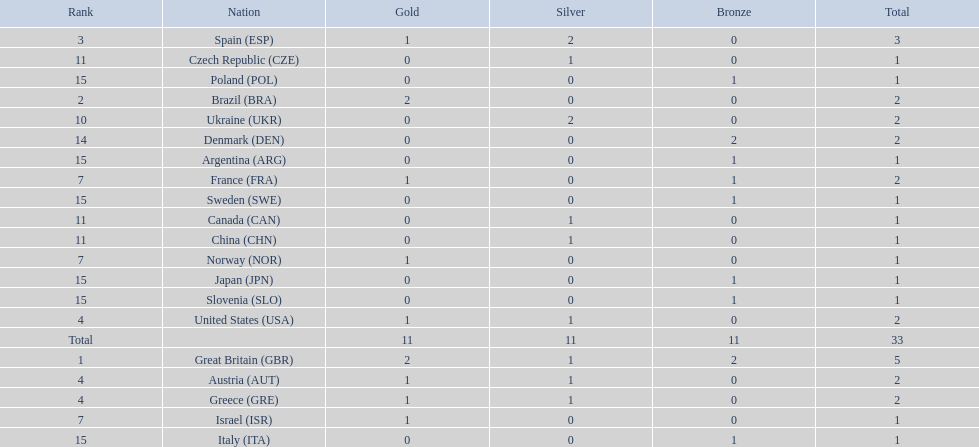What was the total number of medals won by united states? 2. 